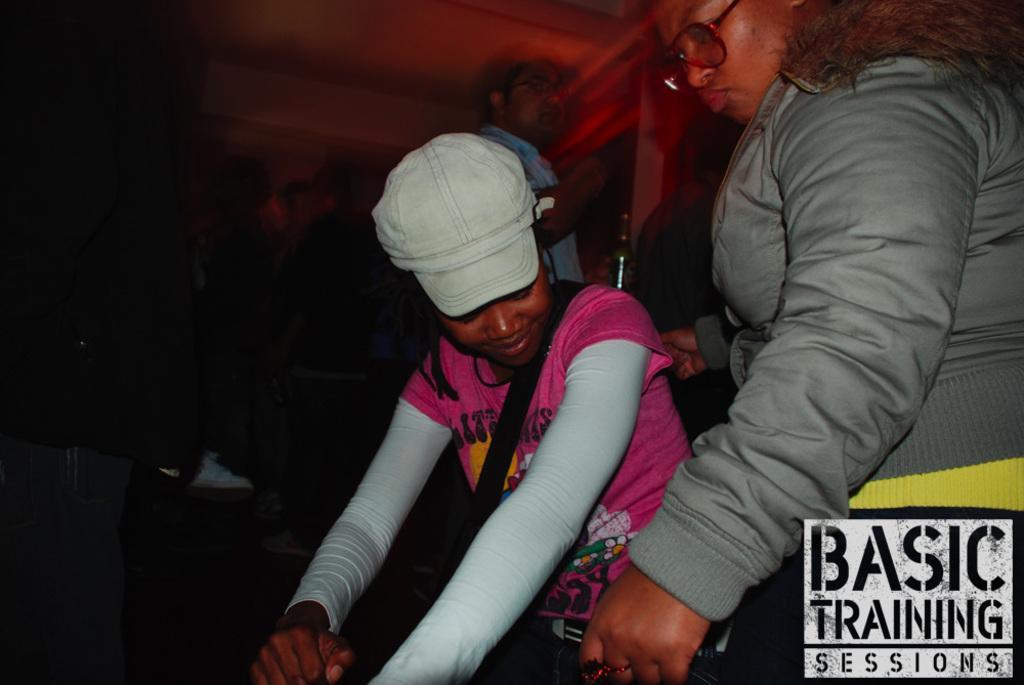Could you give a brief overview of what you see in this image? On the right side, there is a woman in a gray color jacket, wearing a spectacle and holding a belt, which is attached to another person who is in pink color T-Shirt. On the bottom right, there is a watermark. In the background, there is another person standing, there is a roof, a wall and other objects. And the background is dark in color. 